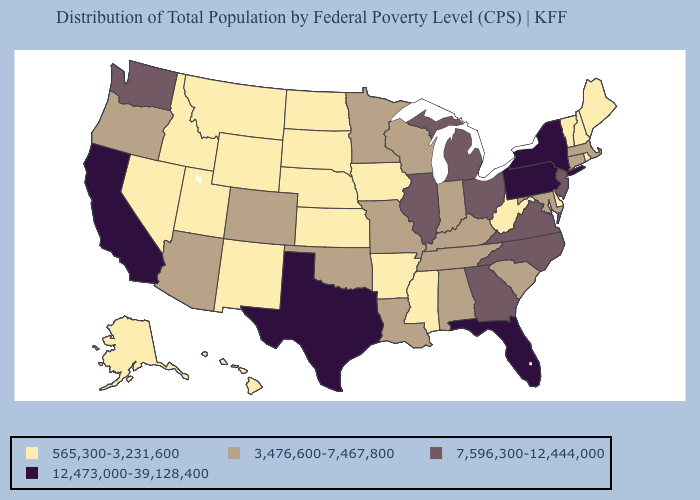What is the highest value in states that border Indiana?
Answer briefly. 7,596,300-12,444,000. Does Kansas have the lowest value in the MidWest?
Concise answer only. Yes. Name the states that have a value in the range 7,596,300-12,444,000?
Answer briefly. Georgia, Illinois, Michigan, New Jersey, North Carolina, Ohio, Virginia, Washington. Among the states that border Illinois , does Missouri have the lowest value?
Concise answer only. No. Does New York have the same value as Pennsylvania?
Quick response, please. Yes. Does Idaho have the lowest value in the USA?
Answer briefly. Yes. Does West Virginia have the lowest value in the South?
Give a very brief answer. Yes. Name the states that have a value in the range 12,473,000-39,128,400?
Be succinct. California, Florida, New York, Pennsylvania, Texas. Among the states that border Minnesota , which have the highest value?
Short answer required. Wisconsin. Does California have the highest value in the West?
Concise answer only. Yes. Name the states that have a value in the range 565,300-3,231,600?
Write a very short answer. Alaska, Arkansas, Delaware, Hawaii, Idaho, Iowa, Kansas, Maine, Mississippi, Montana, Nebraska, Nevada, New Hampshire, New Mexico, North Dakota, Rhode Island, South Dakota, Utah, Vermont, West Virginia, Wyoming. Does West Virginia have the same value as Arizona?
Answer briefly. No. What is the value of Indiana?
Keep it brief. 3,476,600-7,467,800. Does Pennsylvania have the same value as Idaho?
Quick response, please. No. How many symbols are there in the legend?
Concise answer only. 4. 